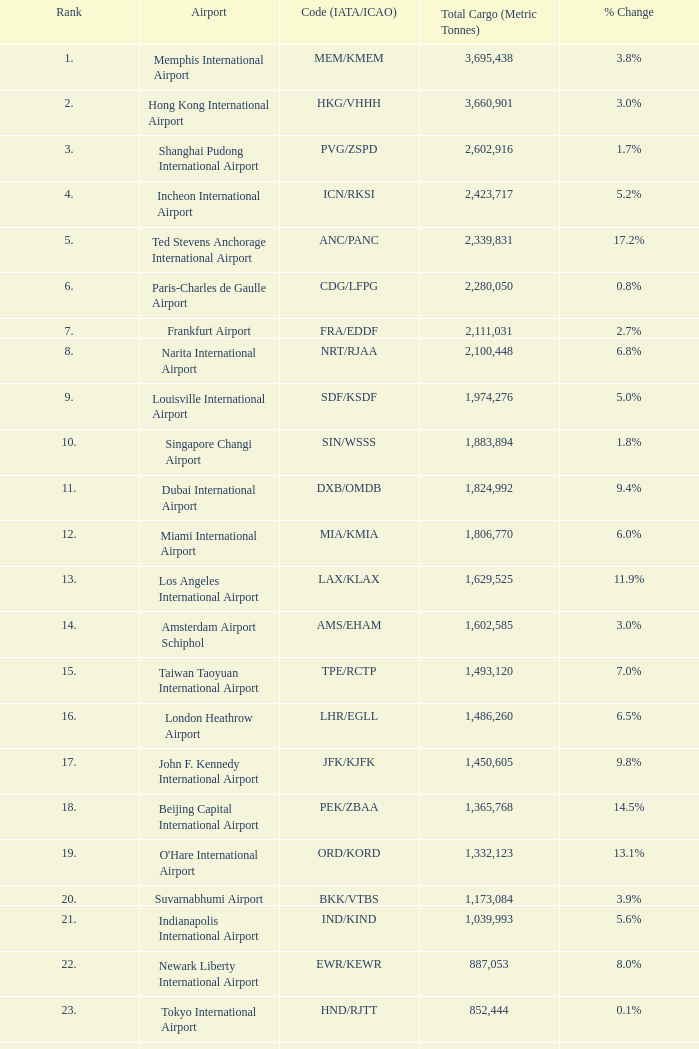What is the standing for ord/kord with more than 1,332,123 total cargo? None. Could you help me parse every detail presented in this table? {'header': ['Rank', 'Airport', 'Code (IATA/ICAO)', 'Total Cargo (Metric Tonnes)', '% Change'], 'rows': [['1.', 'Memphis International Airport', 'MEM/KMEM', '3,695,438', '3.8%'], ['2.', 'Hong Kong International Airport', 'HKG/VHHH', '3,660,901', '3.0%'], ['3.', 'Shanghai Pudong International Airport', 'PVG/ZSPD', '2,602,916', '1.7%'], ['4.', 'Incheon International Airport', 'ICN/RKSI', '2,423,717', '5.2%'], ['5.', 'Ted Stevens Anchorage International Airport', 'ANC/PANC', '2,339,831', '17.2%'], ['6.', 'Paris-Charles de Gaulle Airport', 'CDG/LFPG', '2,280,050', '0.8%'], ['7.', 'Frankfurt Airport', 'FRA/EDDF', '2,111,031', '2.7%'], ['8.', 'Narita International Airport', 'NRT/RJAA', '2,100,448', '6.8%'], ['9.', 'Louisville International Airport', 'SDF/KSDF', '1,974,276', '5.0%'], ['10.', 'Singapore Changi Airport', 'SIN/WSSS', '1,883,894', '1.8%'], ['11.', 'Dubai International Airport', 'DXB/OMDB', '1,824,992', '9.4%'], ['12.', 'Miami International Airport', 'MIA/KMIA', '1,806,770', '6.0%'], ['13.', 'Los Angeles International Airport', 'LAX/KLAX', '1,629,525', '11.9%'], ['14.', 'Amsterdam Airport Schiphol', 'AMS/EHAM', '1,602,585', '3.0%'], ['15.', 'Taiwan Taoyuan International Airport', 'TPE/RCTP', '1,493,120', '7.0%'], ['16.', 'London Heathrow Airport', 'LHR/EGLL', '1,486,260', '6.5%'], ['17.', 'John F. Kennedy International Airport', 'JFK/KJFK', '1,450,605', '9.8%'], ['18.', 'Beijing Capital International Airport', 'PEK/ZBAA', '1,365,768', '14.5%'], ['19.', "O'Hare International Airport", 'ORD/KORD', '1,332,123', '13.1%'], ['20.', 'Suvarnabhumi Airport', 'BKK/VTBS', '1,173,084', '3.9%'], ['21.', 'Indianapolis International Airport', 'IND/KIND', '1,039,993', '5.6%'], ['22.', 'Newark Liberty International Airport', 'EWR/KEWR', '887,053', '8.0%'], ['23.', 'Tokyo International Airport', 'HND/RJTT', '852,444', '0.1%'], ['24.', 'Kansai International Airport', 'KIX/RJBB', '845,497', '0.1%'], ['25.', 'Luxembourg-Findel Airport', 'LUX/ELLX', '788,224', '8.0%'], ['26.', 'Guangzhou Baiyun International Airport', 'CAN/ZGGG', '685,868', '1.3%'], ['27.', 'Kuala Lumpur International Airport', 'KUL/WMKK', '667,495', '2.2%'], ['28.', 'Dallas-Fort Worth International Airport', 'DFW/KDFW', '660,036', '8.7%'], ['29.', 'Brussels Airport', 'BRU/EBBR', '659,054', '11.8%'], ['30.', 'Hartsfield-Jackson Atlanta International Airport', 'ATL/KATL', '655,277', '9.0%']]} 